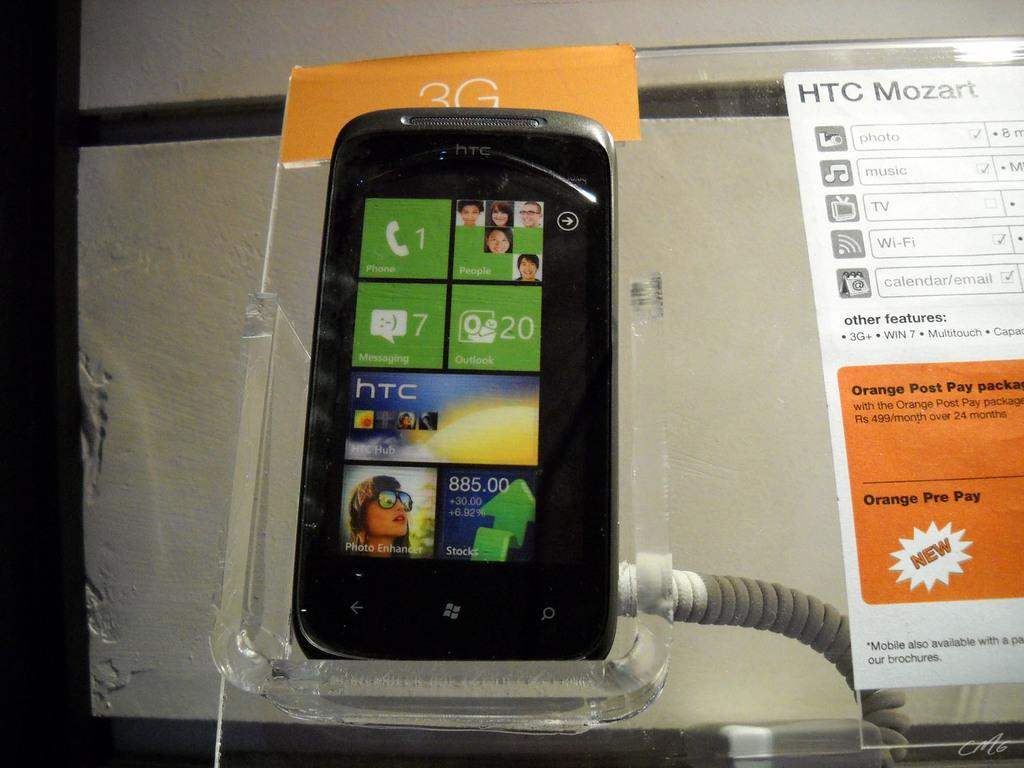<image>
Write a terse but informative summary of the picture. the front of an htc mozart, still in its packaging 